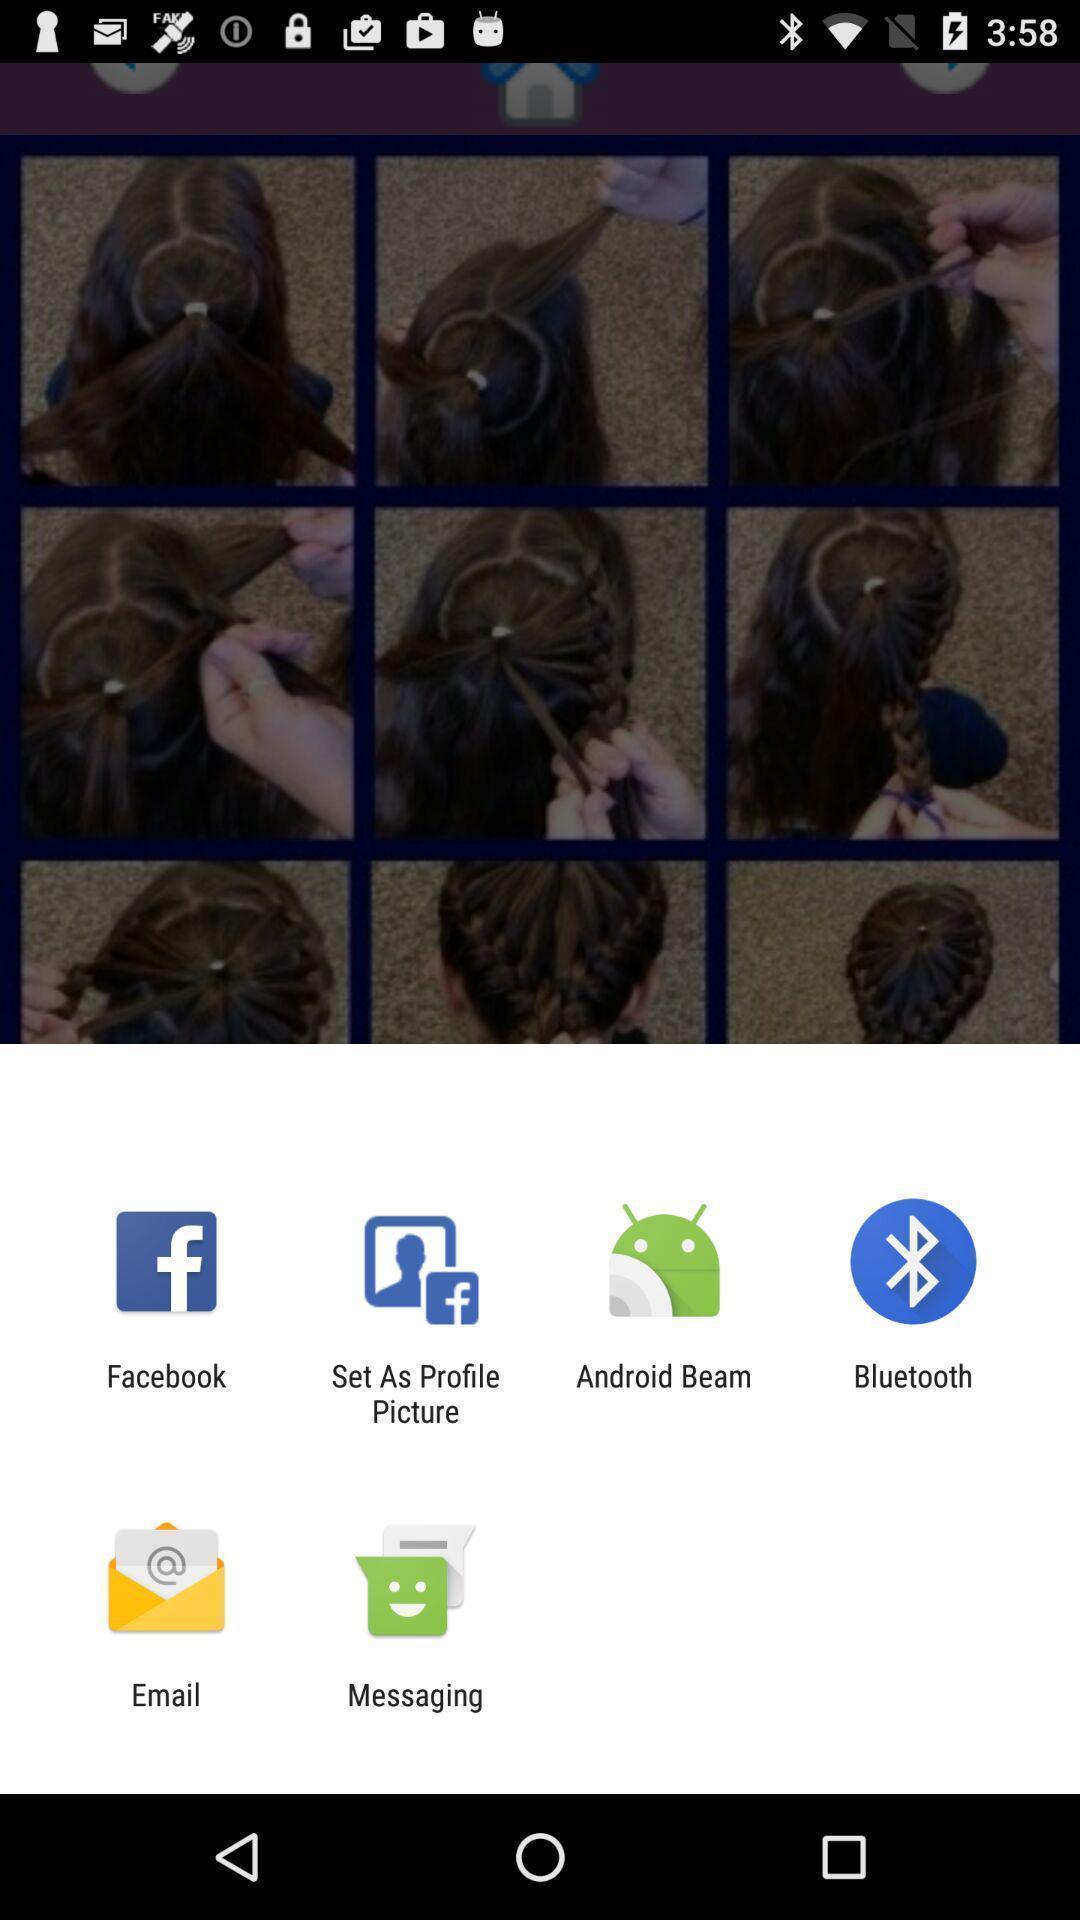Explain the elements present in this screenshot. Pop-up showing the various application. 